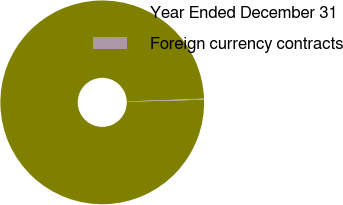Convert chart to OTSL. <chart><loc_0><loc_0><loc_500><loc_500><pie_chart><fcel>Year Ended December 31<fcel>Foreign currency contracts<nl><fcel>99.85%<fcel>0.15%<nl></chart> 